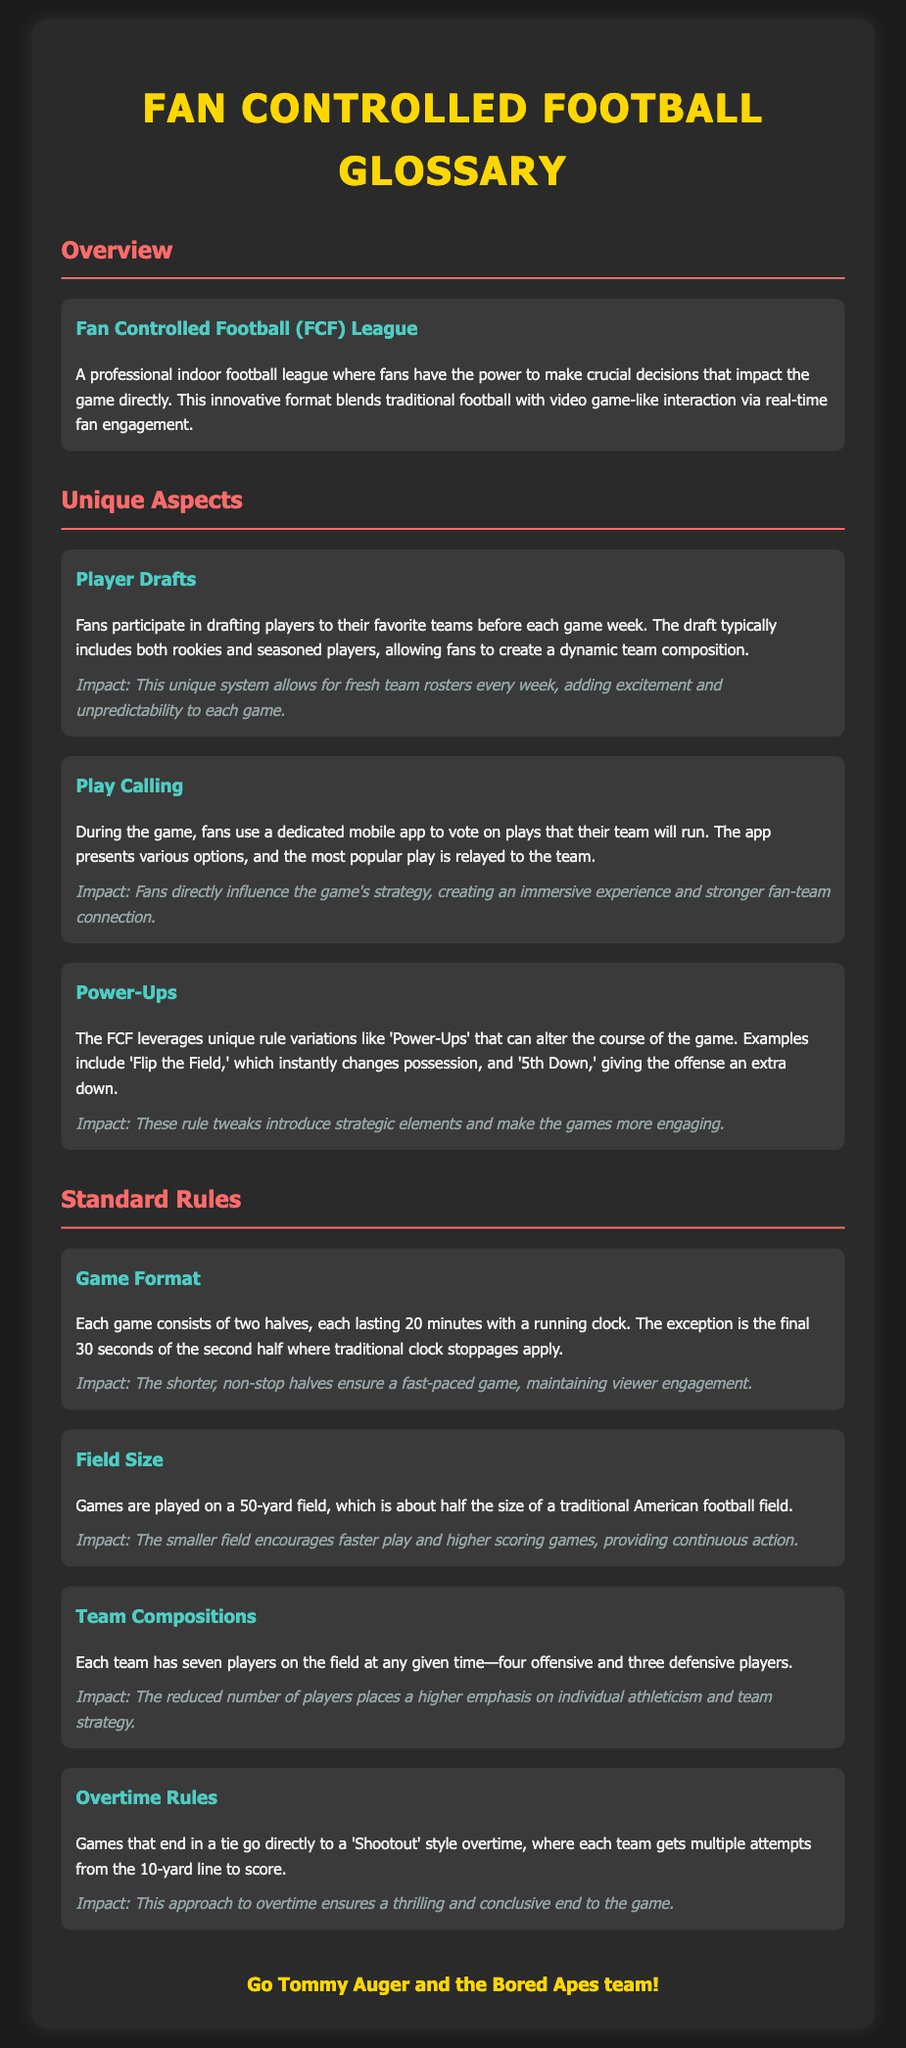what is the name of the league? The name of the league is mentioned in the glossary and is referred to as "Fan Controlled Football (FCF) League."
Answer: Fan Controlled Football (FCF) League how long is each game half? The document states that each half lasts for 20 minutes, providing information about the structure of the game.
Answer: 20 minutes what unique feature allows fans to influence plays during a game? The glossary mentions a feature where fans vote on plays using a dedicated mobile app, highlighting fan engagement in game strategy.
Answer: Play Calling how many players are on the field for each team? The document explains that each team has seven players on the field at any given time, detailing team compositions.
Answer: Seven players what is the field size used in FCF games? The glossary specifies that games are played on a 50-yard field, which is relevant for understanding the game setup.
Answer: 50 yards which term refers to the method of resolving a tie? The document describes a 'Shootout' style overtime for games that end in a tie, providing information about game concluding processes.
Answer: Shootout what is an example of a 'Power-Up' mentioned in the glossary? The glossary provides examples of 'Power-Ups,' one being 'Flip the Field,' which gives insight into the unique rules of the league.
Answer: Flip the Field what color is the header for the glossary title? The document describes the styling of the title header, stating it is presented in a specific color to differentiate it.
Answer: Gold 